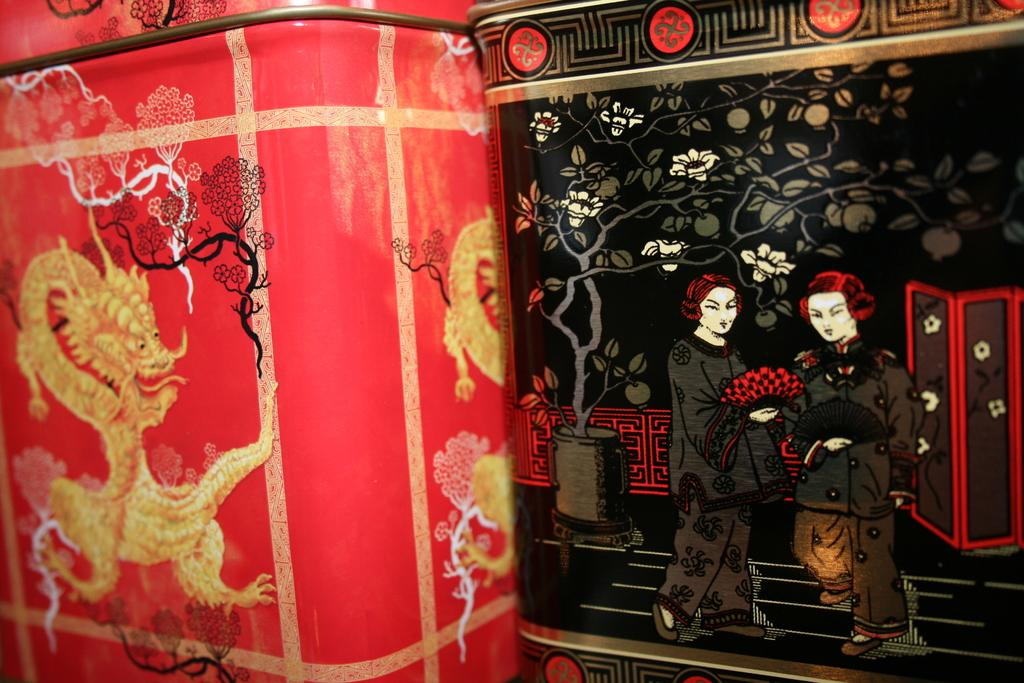What type of objects can be seen in the image? There are boxes of different colors in the image. Can you describe the appearance of the boxes? The boxes have designs on them. What type of salt is sprinkled on the chin of the person in the image? There is no person or salt present in the image; it only features boxes with designs. 